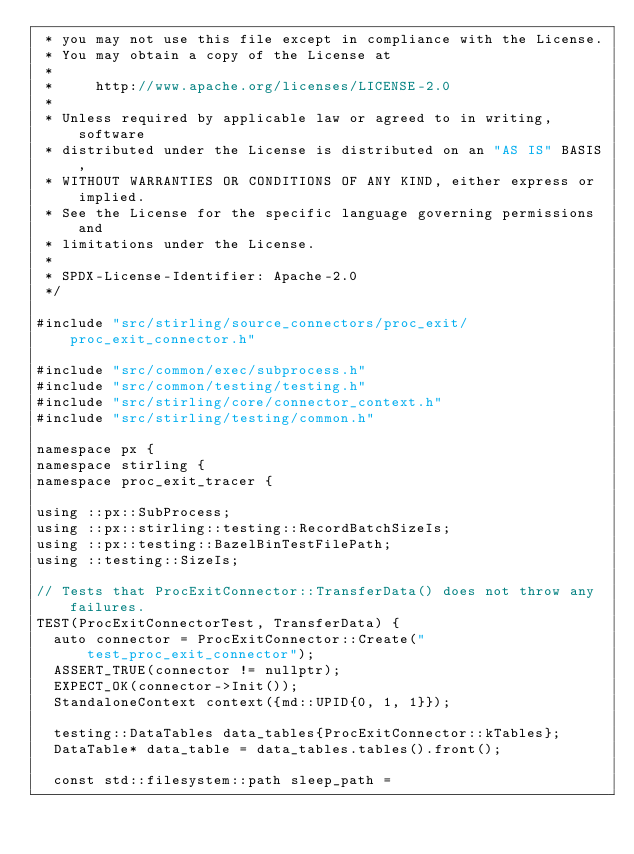<code> <loc_0><loc_0><loc_500><loc_500><_C++_> * you may not use this file except in compliance with the License.
 * You may obtain a copy of the License at
 *
 *     http://www.apache.org/licenses/LICENSE-2.0
 *
 * Unless required by applicable law or agreed to in writing, software
 * distributed under the License is distributed on an "AS IS" BASIS,
 * WITHOUT WARRANTIES OR CONDITIONS OF ANY KIND, either express or implied.
 * See the License for the specific language governing permissions and
 * limitations under the License.
 *
 * SPDX-License-Identifier: Apache-2.0
 */

#include "src/stirling/source_connectors/proc_exit/proc_exit_connector.h"

#include "src/common/exec/subprocess.h"
#include "src/common/testing/testing.h"
#include "src/stirling/core/connector_context.h"
#include "src/stirling/testing/common.h"

namespace px {
namespace stirling {
namespace proc_exit_tracer {

using ::px::SubProcess;
using ::px::stirling::testing::RecordBatchSizeIs;
using ::px::testing::BazelBinTestFilePath;
using ::testing::SizeIs;

// Tests that ProcExitConnector::TransferData() does not throw any failures.
TEST(ProcExitConnectorTest, TransferData) {
  auto connector = ProcExitConnector::Create("test_proc_exit_connector");
  ASSERT_TRUE(connector != nullptr);
  EXPECT_OK(connector->Init());
  StandaloneContext context({md::UPID{0, 1, 1}});

  testing::DataTables data_tables{ProcExitConnector::kTables};
  DataTable* data_table = data_tables.tables().front();

  const std::filesystem::path sleep_path =</code> 